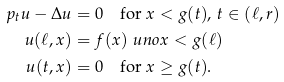Convert formula to latex. <formula><loc_0><loc_0><loc_500><loc_500>\ p _ { t } u - \Delta u & = 0 \quad \text {for } x < g ( t ) , \, t \in ( \ell , r ) \\ u ( \ell , x ) & = f ( x ) \ u n o { x < g ( \ell ) } \\ u ( t , x ) & = 0 \quad \text {for } x \geq g ( t ) .</formula> 